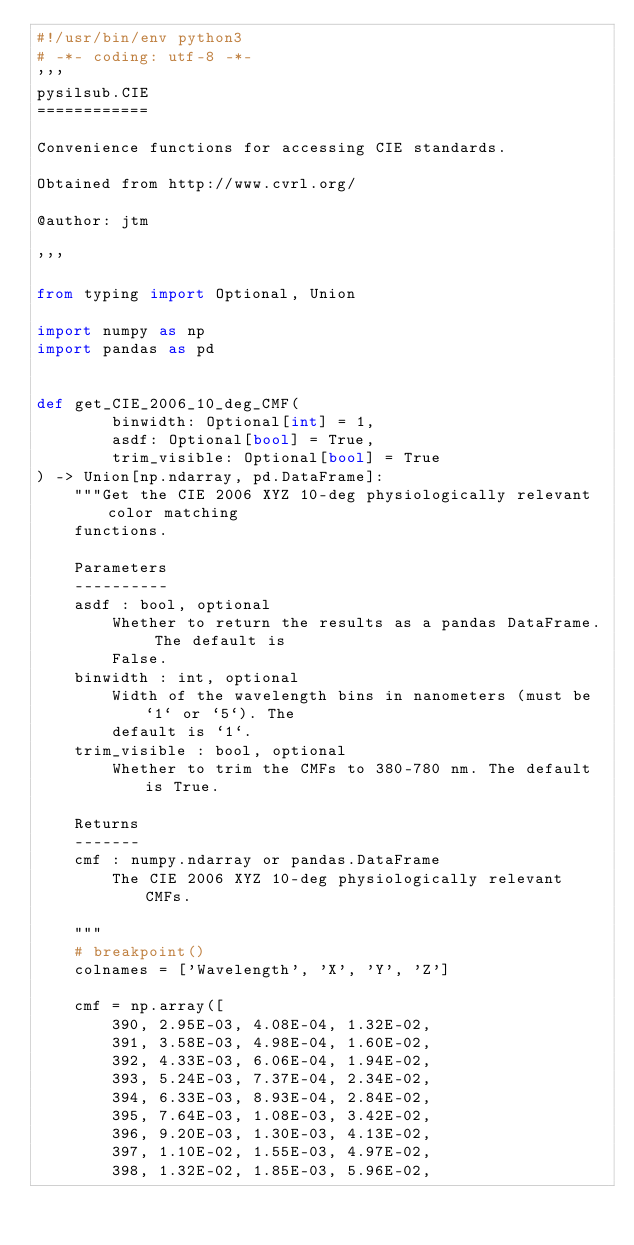<code> <loc_0><loc_0><loc_500><loc_500><_Python_>#!/usr/bin/env python3
# -*- coding: utf-8 -*-
'''
pysilsub.CIE
============

Convenience functions for accessing CIE standards.

Obtained from http://www.cvrl.org/

@author: jtm

'''

from typing import Optional, Union

import numpy as np
import pandas as pd


def get_CIE_2006_10_deg_CMF(
        binwidth: Optional[int] = 1,
        asdf: Optional[bool] = True,
        trim_visible: Optional[bool] = True
) -> Union[np.ndarray, pd.DataFrame]:
    """Get the CIE 2006 XYZ 10-deg physiologically relevant color matching
    functions.

    Parameters
    ----------
    asdf : bool, optional
        Whether to return the results as a pandas DataFrame. The default is
        False.
    binwidth : int, optional
        Width of the wavelength bins in nanometers (must be `1` or `5`). The
        default is `1`.
    trim_visible : bool, optional
        Whether to trim the CMFs to 380-780 nm. The default is True.

    Returns
    -------
    cmf : numpy.ndarray or pandas.DataFrame
        The CIE 2006 XYZ 10-deg physiologically relevant CMFs.

    """
    # breakpoint()
    colnames = ['Wavelength', 'X', 'Y', 'Z']

    cmf = np.array([
        390, 2.95E-03, 4.08E-04, 1.32E-02,
        391, 3.58E-03, 4.98E-04, 1.60E-02,
        392, 4.33E-03, 6.06E-04, 1.94E-02,
        393, 5.24E-03, 7.37E-04, 2.34E-02,
        394, 6.33E-03, 8.93E-04, 2.84E-02,
        395, 7.64E-03, 1.08E-03, 3.42E-02,
        396, 9.20E-03, 1.30E-03, 4.13E-02,
        397, 1.10E-02, 1.55E-03, 4.97E-02,
        398, 1.32E-02, 1.85E-03, 5.96E-02,</code> 